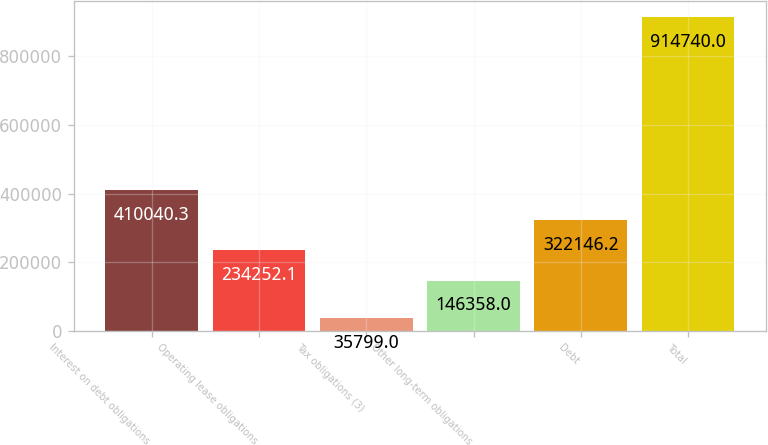<chart> <loc_0><loc_0><loc_500><loc_500><bar_chart><fcel>Interest on debt obligations<fcel>Operating lease obligations<fcel>Tax obligations (3)<fcel>Other long-term obligations<fcel>Debt<fcel>Total<nl><fcel>410040<fcel>234252<fcel>35799<fcel>146358<fcel>322146<fcel>914740<nl></chart> 